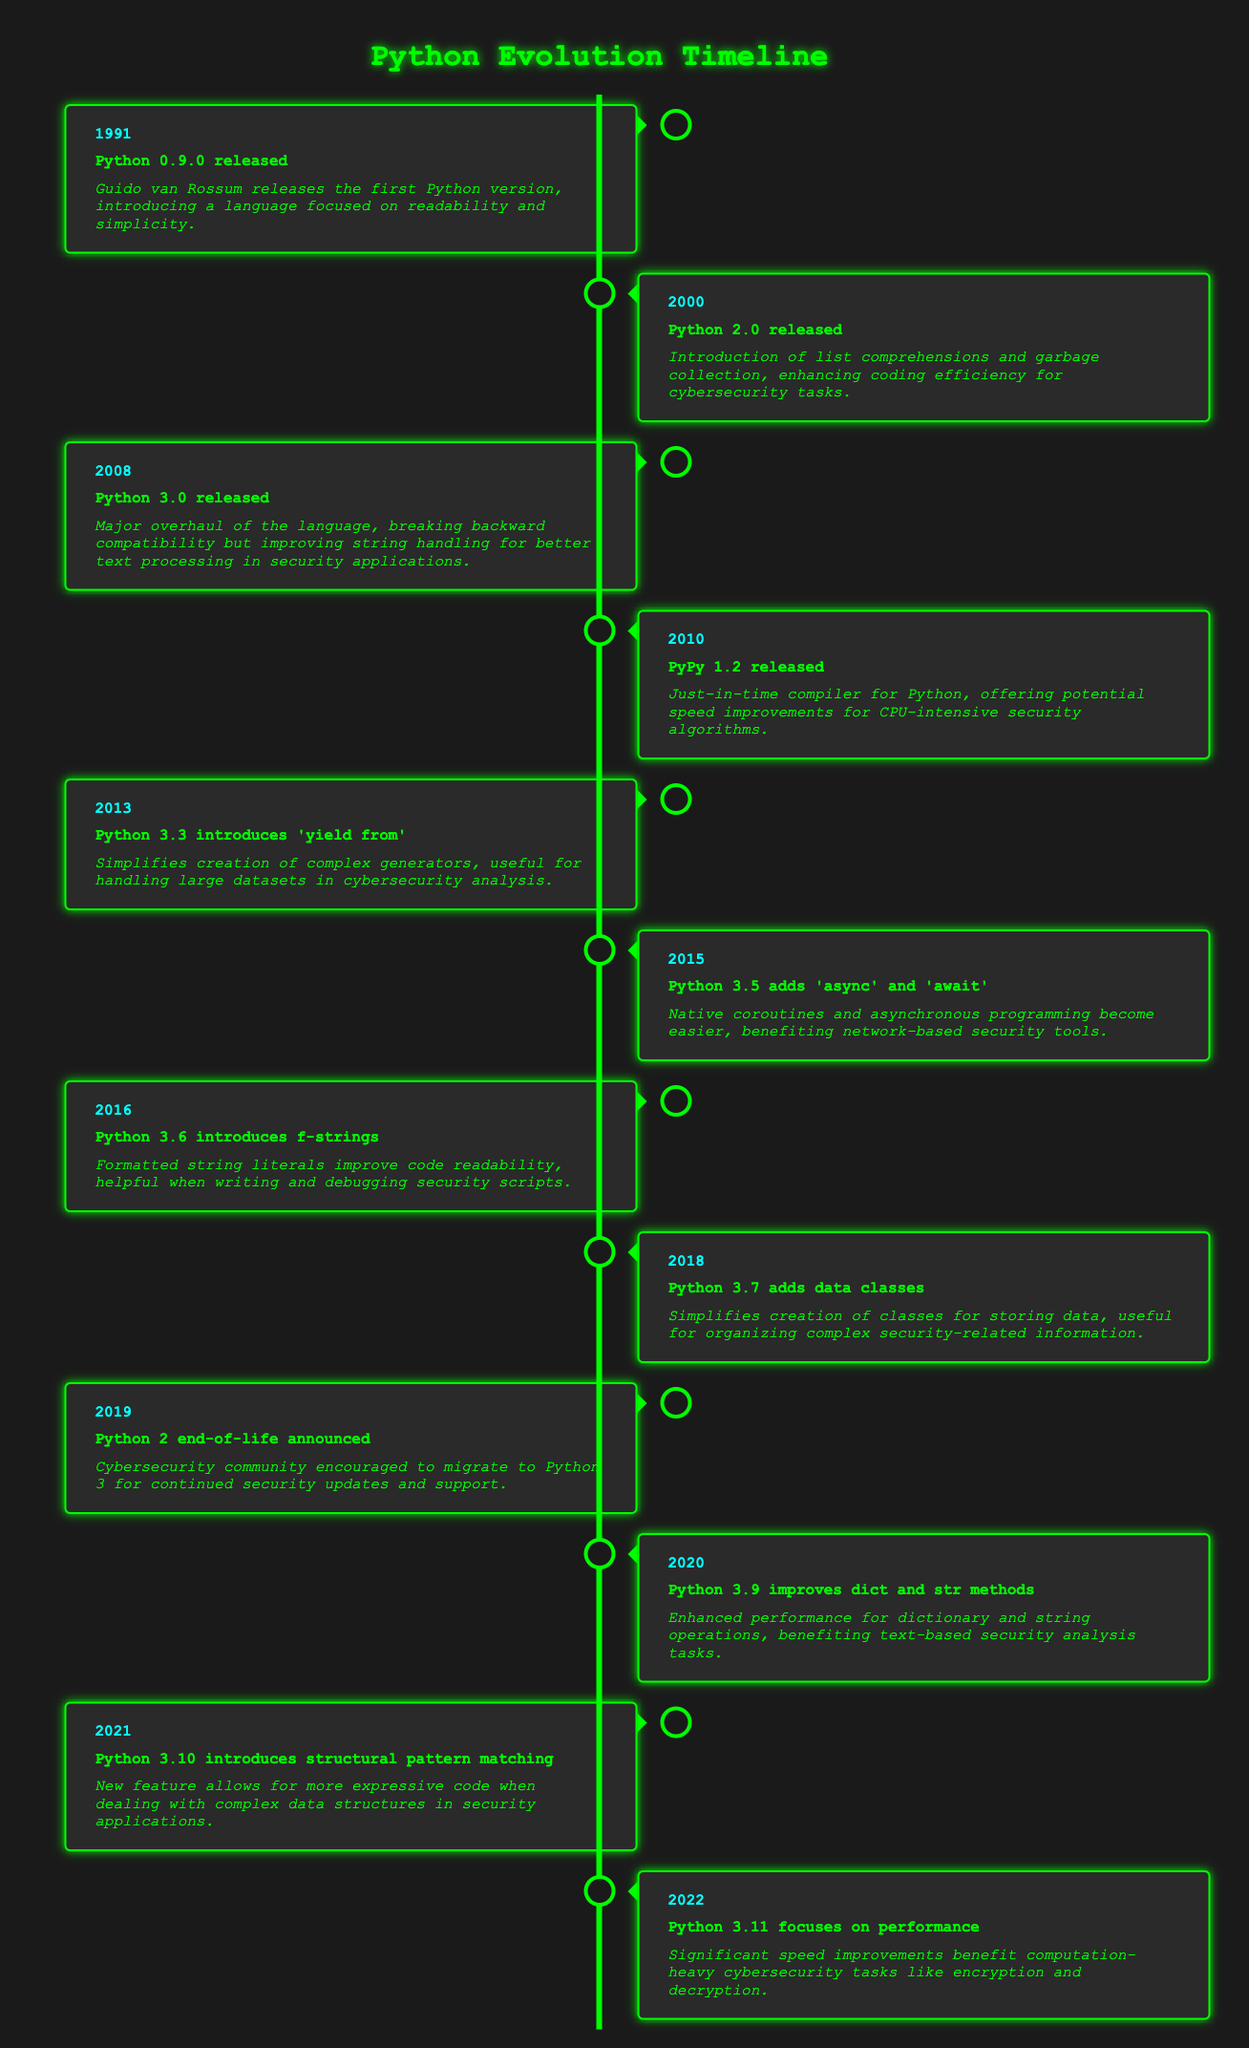What year was Python 3.0 released? The event "Python 3.0 released" is listed in the row for the year 2008. Therefore, Python 3.0 was released in 2008.
Answer: 2008 What is the main feature introduced in Python 2.0? According to the description for the event "Python 2.0 released," it introduced list comprehensions and garbage collection.
Answer: List comprehensions and garbage collection When did the Python 2 end-of-life get announced? The timeline indicates that the "Python 2 end-of-life announced" event occurred in the year 2019.
Answer: 2019 What major improvements were made in Python 3.11? The event "Python 3.11 focuses on performance" highlights that significant speed improvements were made, which could benefit computation-heavy tasks.
Answer: Significant speed improvements How many years are there between the release of Python 0.9.0 and Python 3.0? Python 0.9.0 was released in 1991 and Python 3.0 in 2008. The difference is 2008 - 1991 = 17 years.
Answer: 17 years Did Python 3.5 introduce synchronous programming features? The description for Python 3.5 states it added 'async' and 'await', which are related to asynchronous rather than synchronous programming. Therefore, the answer is no.
Answer: No Which event marks the transition from Python 2 to Python 3 in terms of being a major version? Evaluating the timeline, Python 3.0 is the significant event that represents the change to Python 3, given that it was a major overhaul and was released in 2008, breaking backward compatibility.
Answer: Python 3.0 released How many versions were released between Python 2.0 and the announcement of Python 2 end-of-life? From Python 2.0 in 2000 to Python 2 end-of-life in 2019, we have the versions Python 3.0 (2008), Python 3.3 (2013), Python 3.5 (2015), Python 3.6 (2016), Python 3.7 (2018), and Python 3.9 (2020), totaling 6 versions between those years.
Answer: 6 versions What specific benefit do formatted string literals (f-strings) provide in Python 3.6? The description for Python 3.6 mentions that f-strings improve code readability, which is helpful in writing and debugging scripts. Hence, the specific benefit is improved readability.
Answer: Improved readability What were the focus areas of Python 3.11 compared to earlier versions? Python 3.11 focuses on performance improvements, indicating a shift towards optimizing speed for heavy computational tasks, unlike earlier versions that emphasized features like data classes and async programming.
Answer: Performance improvements 